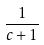<formula> <loc_0><loc_0><loc_500><loc_500>\frac { 1 } { c + 1 }</formula> 